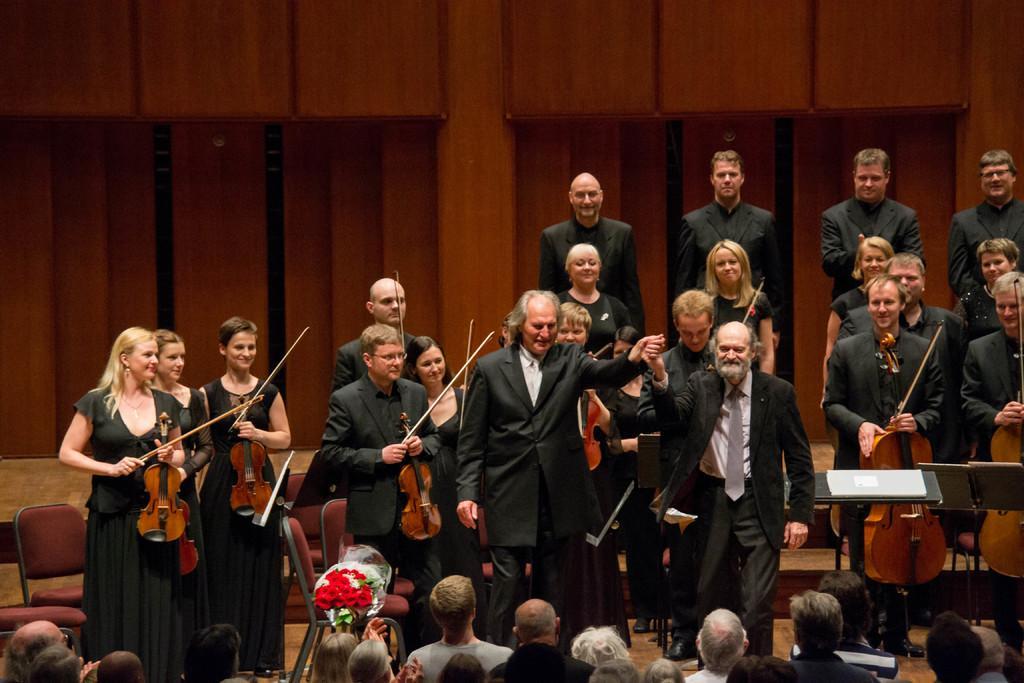Please provide a concise description of this image. In this image I can see number of people were few of them are holding musical instruments. I can also see smile on few faces. Here I can see a flower bouquet. I can also see few chairs over here. 